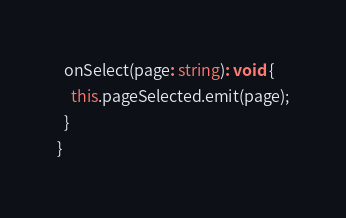<code> <loc_0><loc_0><loc_500><loc_500><_TypeScript_>
  onSelect(page: string): void {
    this.pageSelected.emit(page);
  }
}
</code> 